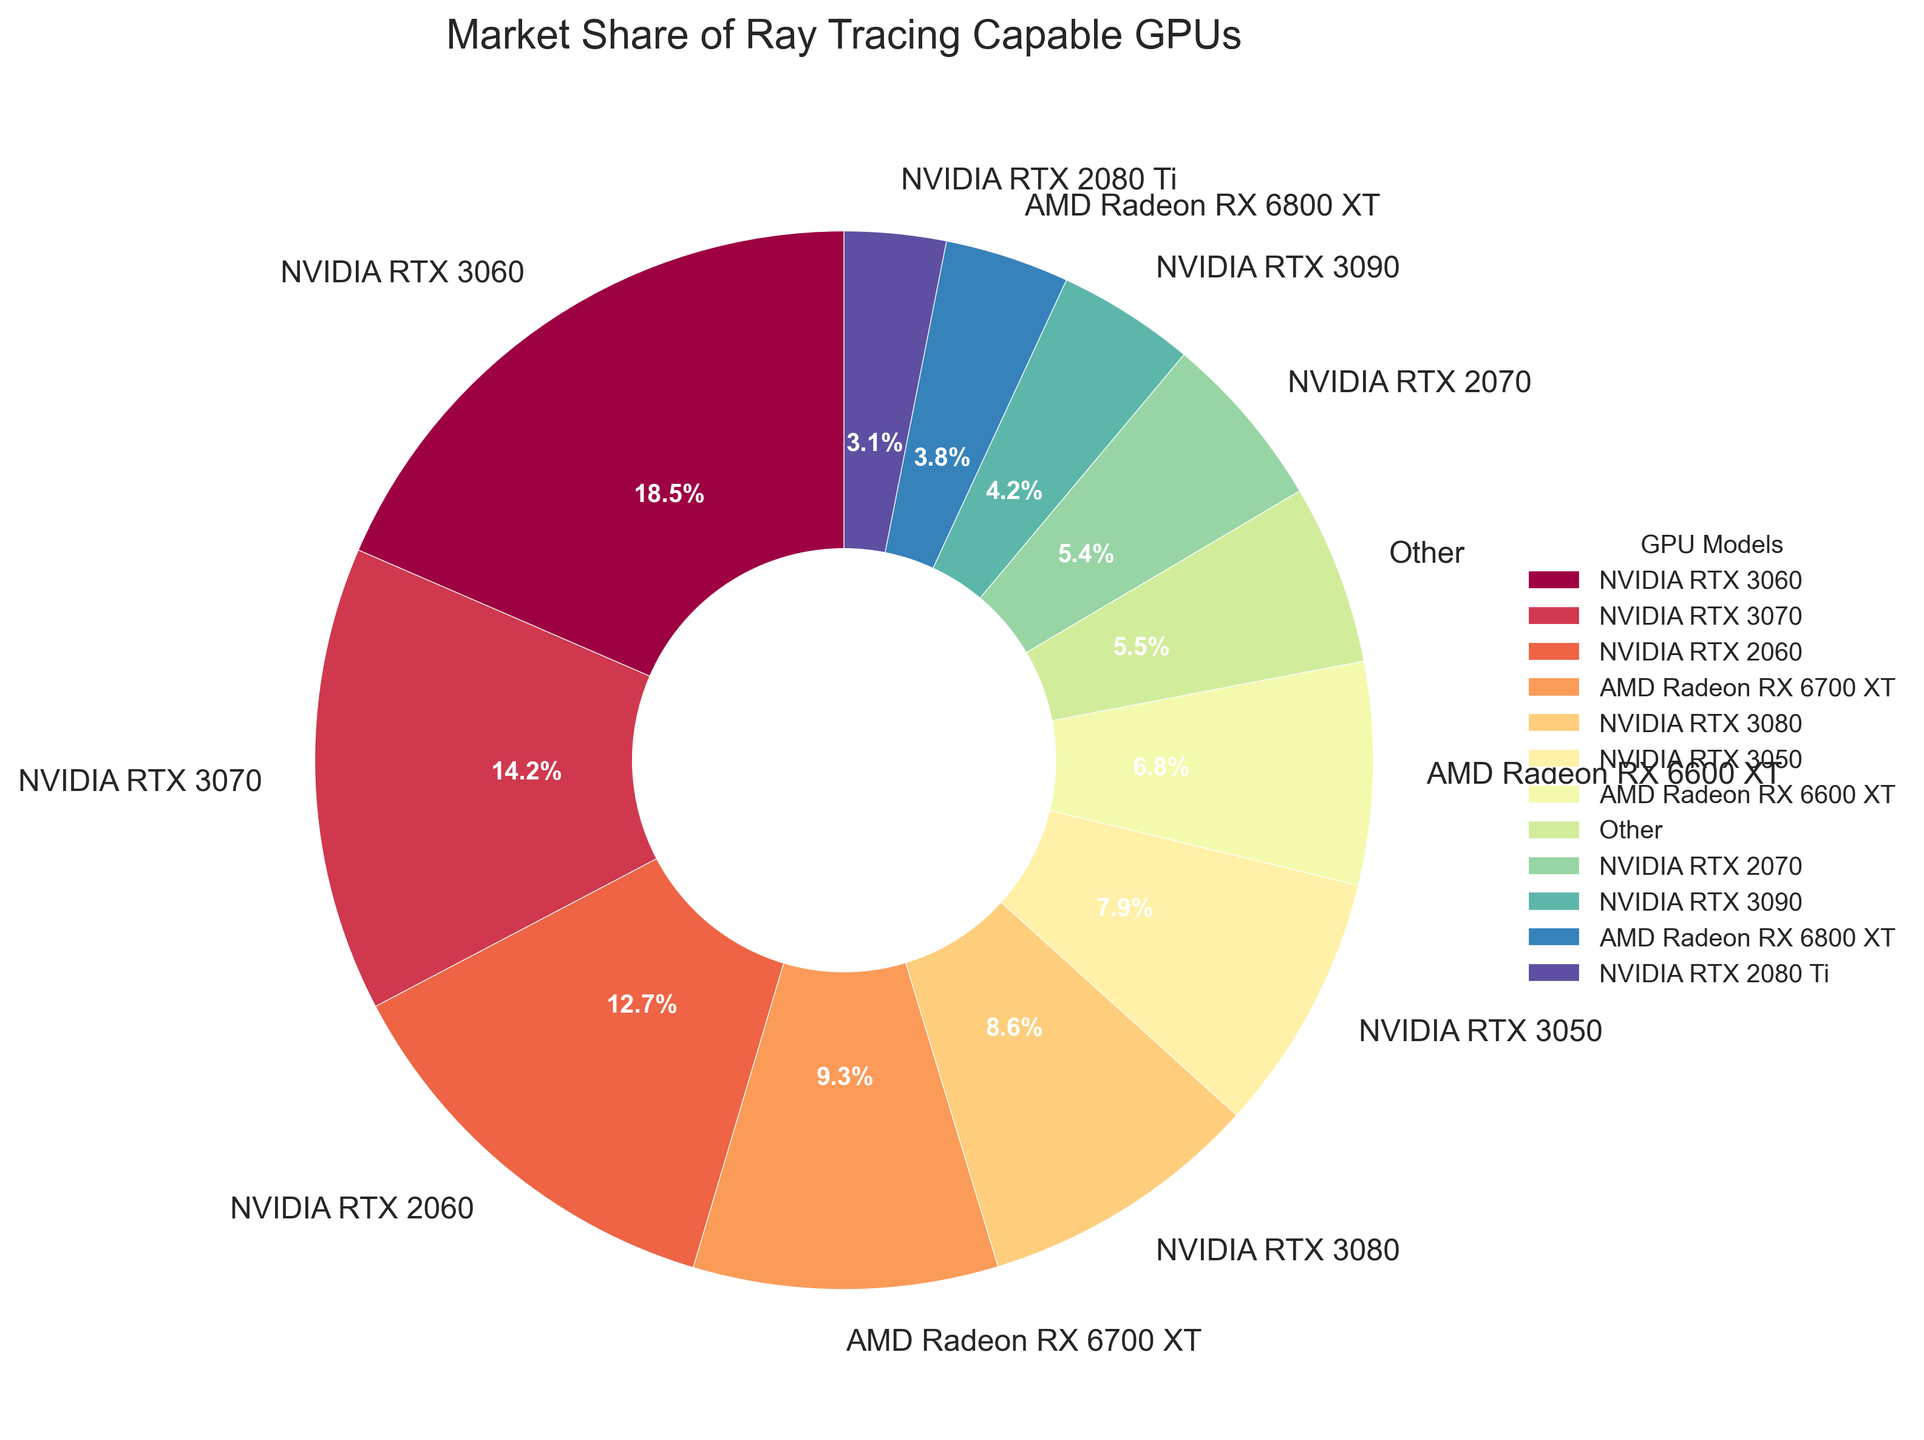What's the largest market share held by a single GPU model? Locate the largest slice of the pie and identify the GPU model associated with that slice. The corresponding percentage will be the largest market share.
Answer: NVIDIA RTX 3060, 18.5% Which GPU models have a market share greater than 10%? Identify the slices in the pie chart that have a percentage greater than 10%. List out the GPU models corresponding to those slices.
Answer: NVIDIA RTX 3060, NVIDIA RTX 3070, NVIDIA RTX 2060 Are there more GPUs with a market share less than 5% or more than 5%? Count the number of GPU models with a market share less than 5% and compare it with the count of GPU models with more than 5%.
Answer: More than 5% What's the combined market share of the NVIDIA RTX 3080 and AMD Radeon RX 6700 XT? Locate the slices for NVIDIA RTX 3080 and AMD Radeon RX 6700 XT. Sum their market share percentages: 8.6% + 9.3% = 17.9%.
Answer: 17.9% Which GPU model has the smallest market share? Identify the smallest slice of the pie and note the GPU model associated with it.
Answer: Intel Arc A770 How does the market share of the NVIDIA RTX 2070 compare to the AMD Radeon RX 6700 XT? Locate the slices for NVIDIA RTX 2070 and AMD Radeon RX 6700 XT. Compare their percentages: 5.4% vs 9.3%.
Answer: The NVIDIA RTX 2070 has a smaller market share What is the difference in the market share between the NVIDIA RTX 2070 and the NVIDIA RTX 2060? Subtract the market share of the NVIDIA RTX 2070 (5.4%) from the NVIDIA RTX 2060 (12.7%): 12.7% - 5.4% = 7.3%.
Answer: 7.3% What is the total market share for all AMD GPUs? Sum the market share percentages of all AMD GPUs from the chart: 9.3% + 6.8% + 3.8% + 2.7% = 22.6%.
Answer: 22.6% How many GPU models fall into the "Other" category? Count the number of GPU models with a market share below 3.0%. These will be grouped into "Other". There are 4 models: RTX 2080 Ti, RX 6900 XT, RTX A6000, and Arc A770.
Answer: 4 